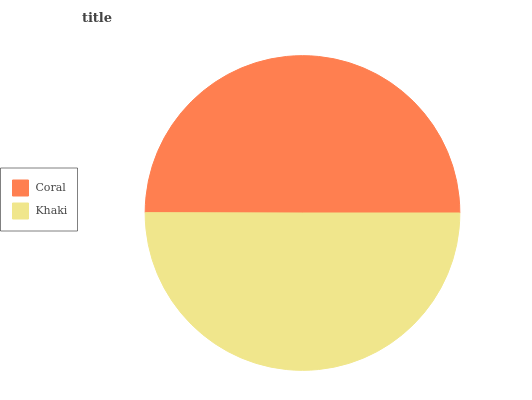Is Coral the minimum?
Answer yes or no. Yes. Is Khaki the maximum?
Answer yes or no. Yes. Is Khaki the minimum?
Answer yes or no. No. Is Khaki greater than Coral?
Answer yes or no. Yes. Is Coral less than Khaki?
Answer yes or no. Yes. Is Coral greater than Khaki?
Answer yes or no. No. Is Khaki less than Coral?
Answer yes or no. No. Is Khaki the high median?
Answer yes or no. Yes. Is Coral the low median?
Answer yes or no. Yes. Is Coral the high median?
Answer yes or no. No. Is Khaki the low median?
Answer yes or no. No. 